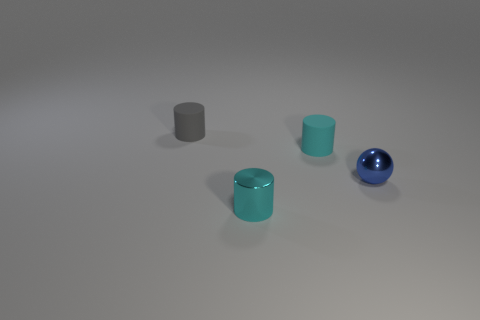Subtract all small cyan rubber cylinders. How many cylinders are left? 2 Add 3 small shiny cylinders. How many objects exist? 7 Subtract all gray cylinders. How many cylinders are left? 2 Subtract all cylinders. How many objects are left? 1 Subtract 1 spheres. How many spheres are left? 0 Subtract all metallic things. Subtract all rubber cylinders. How many objects are left? 0 Add 3 tiny blue metal things. How many tiny blue metal things are left? 4 Add 4 matte spheres. How many matte spheres exist? 4 Subtract 0 gray cubes. How many objects are left? 4 Subtract all green balls. Subtract all yellow blocks. How many balls are left? 1 